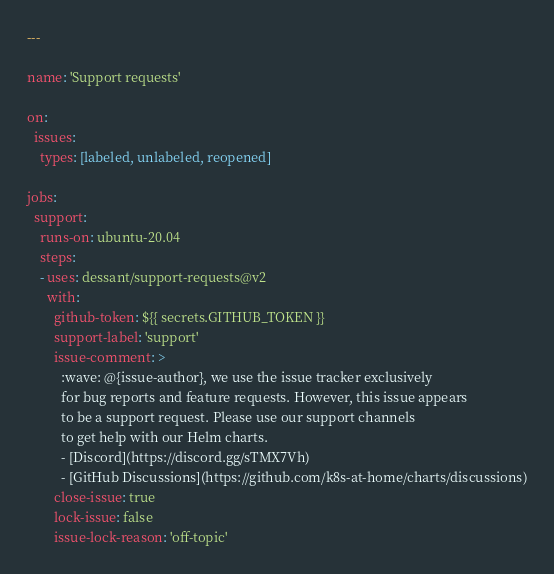<code> <loc_0><loc_0><loc_500><loc_500><_YAML_>---

name: 'Support requests'

on:
  issues:
    types: [labeled, unlabeled, reopened]

jobs:
  support:
    runs-on: ubuntu-20.04
    steps:
    - uses: dessant/support-requests@v2
      with:
        github-token: ${{ secrets.GITHUB_TOKEN }}
        support-label: 'support'
        issue-comment: >
          :wave: @{issue-author}, we use the issue tracker exclusively
          for bug reports and feature requests. However, this issue appears
          to be a support request. Please use our support channels
          to get help with our Helm charts.
          - [Discord](https://discord.gg/sTMX7Vh)
          - [GitHub Discussions](https://github.com/k8s-at-home/charts/discussions)
        close-issue: true
        lock-issue: false
        issue-lock-reason: 'off-topic'
</code> 